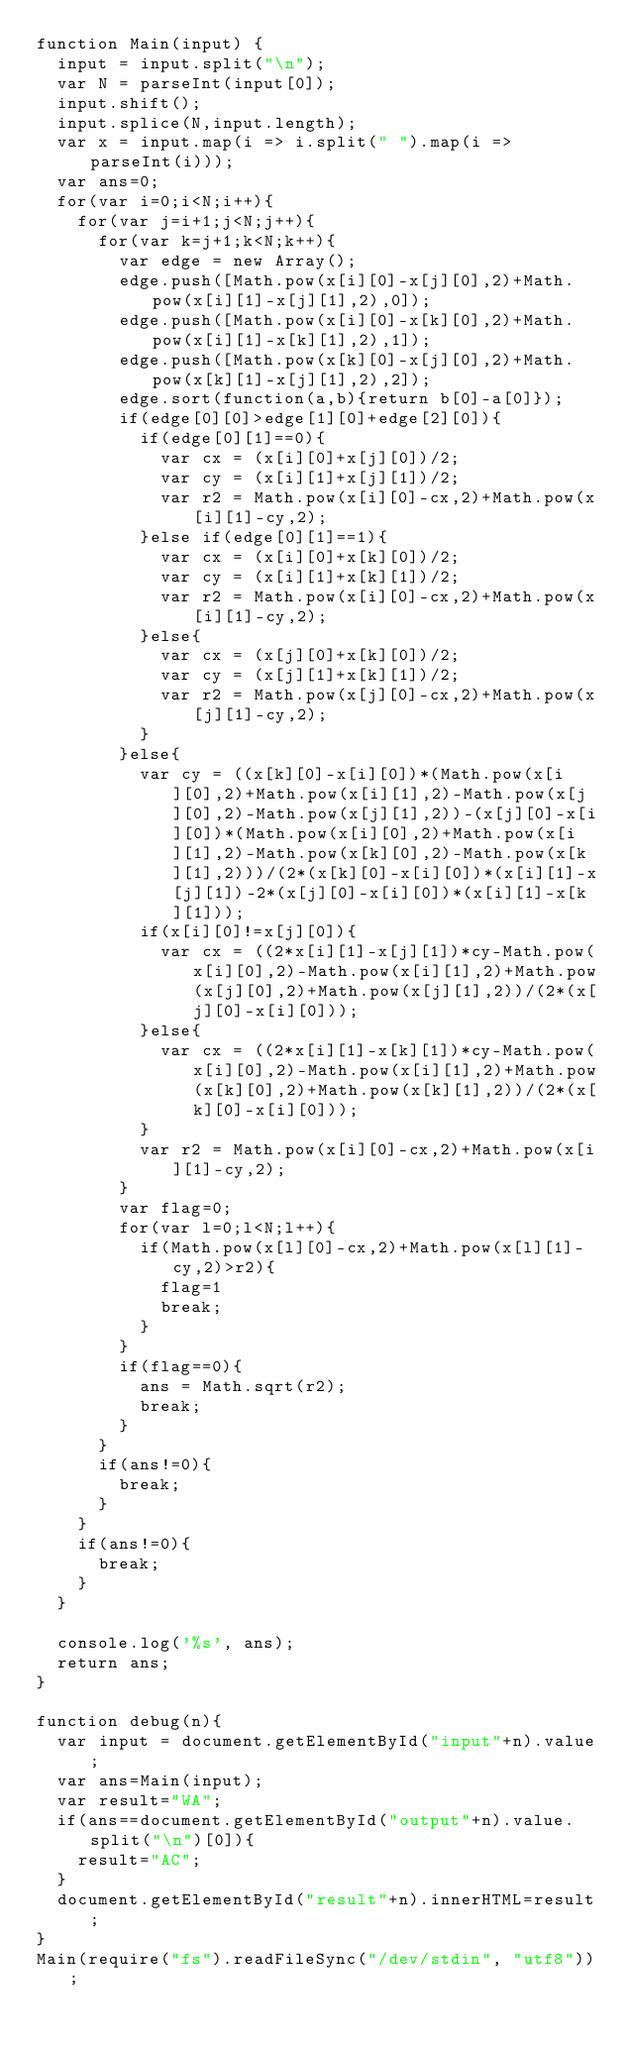Convert code to text. <code><loc_0><loc_0><loc_500><loc_500><_JavaScript_>function Main(input) {
  input = input.split("\n");
  var N = parseInt(input[0]);
  input.shift();
  input.splice(N,input.length);
  var x = input.map(i => i.split(" ").map(i => parseInt(i)));
  var ans=0;
  for(var i=0;i<N;i++){
    for(var j=i+1;j<N;j++){
      for(var k=j+1;k<N;k++){
        var edge = new Array();
        edge.push([Math.pow(x[i][0]-x[j][0],2)+Math.pow(x[i][1]-x[j][1],2),0]);
        edge.push([Math.pow(x[i][0]-x[k][0],2)+Math.pow(x[i][1]-x[k][1],2),1]);
        edge.push([Math.pow(x[k][0]-x[j][0],2)+Math.pow(x[k][1]-x[j][1],2),2]);
        edge.sort(function(a,b){return b[0]-a[0]});
        if(edge[0][0]>edge[1][0]+edge[2][0]){
          if(edge[0][1]==0){
            var cx = (x[i][0]+x[j][0])/2;
            var cy = (x[i][1]+x[j][1])/2;
            var r2 = Math.pow(x[i][0]-cx,2)+Math.pow(x[i][1]-cy,2);
          }else if(edge[0][1]==1){
            var cx = (x[i][0]+x[k][0])/2;
            var cy = (x[i][1]+x[k][1])/2;
            var r2 = Math.pow(x[i][0]-cx,2)+Math.pow(x[i][1]-cy,2);
          }else{
            var cx = (x[j][0]+x[k][0])/2;
            var cy = (x[j][1]+x[k][1])/2;
            var r2 = Math.pow(x[j][0]-cx,2)+Math.pow(x[j][1]-cy,2);
          }
        }else{
          var cy = ((x[k][0]-x[i][0])*(Math.pow(x[i][0],2)+Math.pow(x[i][1],2)-Math.pow(x[j][0],2)-Math.pow(x[j][1],2))-(x[j][0]-x[i][0])*(Math.pow(x[i][0],2)+Math.pow(x[i][1],2)-Math.pow(x[k][0],2)-Math.pow(x[k][1],2)))/(2*(x[k][0]-x[i][0])*(x[i][1]-x[j][1])-2*(x[j][0]-x[i][0])*(x[i][1]-x[k][1]));
          if(x[i][0]!=x[j][0]){
            var cx = ((2*x[i][1]-x[j][1])*cy-Math.pow(x[i][0],2)-Math.pow(x[i][1],2)+Math.pow(x[j][0],2)+Math.pow(x[j][1],2))/(2*(x[j][0]-x[i][0]));
          }else{
            var cx = ((2*x[i][1]-x[k][1])*cy-Math.pow(x[i][0],2)-Math.pow(x[i][1],2)+Math.pow(x[k][0],2)+Math.pow(x[k][1],2))/(2*(x[k][0]-x[i][0]));
          }
          var r2 = Math.pow(x[i][0]-cx,2)+Math.pow(x[i][1]-cy,2);
        }
        var flag=0;
        for(var l=0;l<N;l++){
          if(Math.pow(x[l][0]-cx,2)+Math.pow(x[l][1]-cy,2)>r2){
            flag=1
            break;
          }
        }
        if(flag==0){
          ans = Math.sqrt(r2);
          break;
        }
      }
      if(ans!=0){
        break;
      }
    }
    if(ans!=0){
      break;
    }
  }

  console.log('%s', ans);
  return ans;
}

function debug(n){
  var input = document.getElementById("input"+n).value;
  var ans=Main(input);
  var result="WA";
  if(ans==document.getElementById("output"+n).value.split("\n")[0]){
    result="AC";
  }
  document.getElementById("result"+n).innerHTML=result;
}
Main(require("fs").readFileSync("/dev/stdin", "utf8"));</code> 